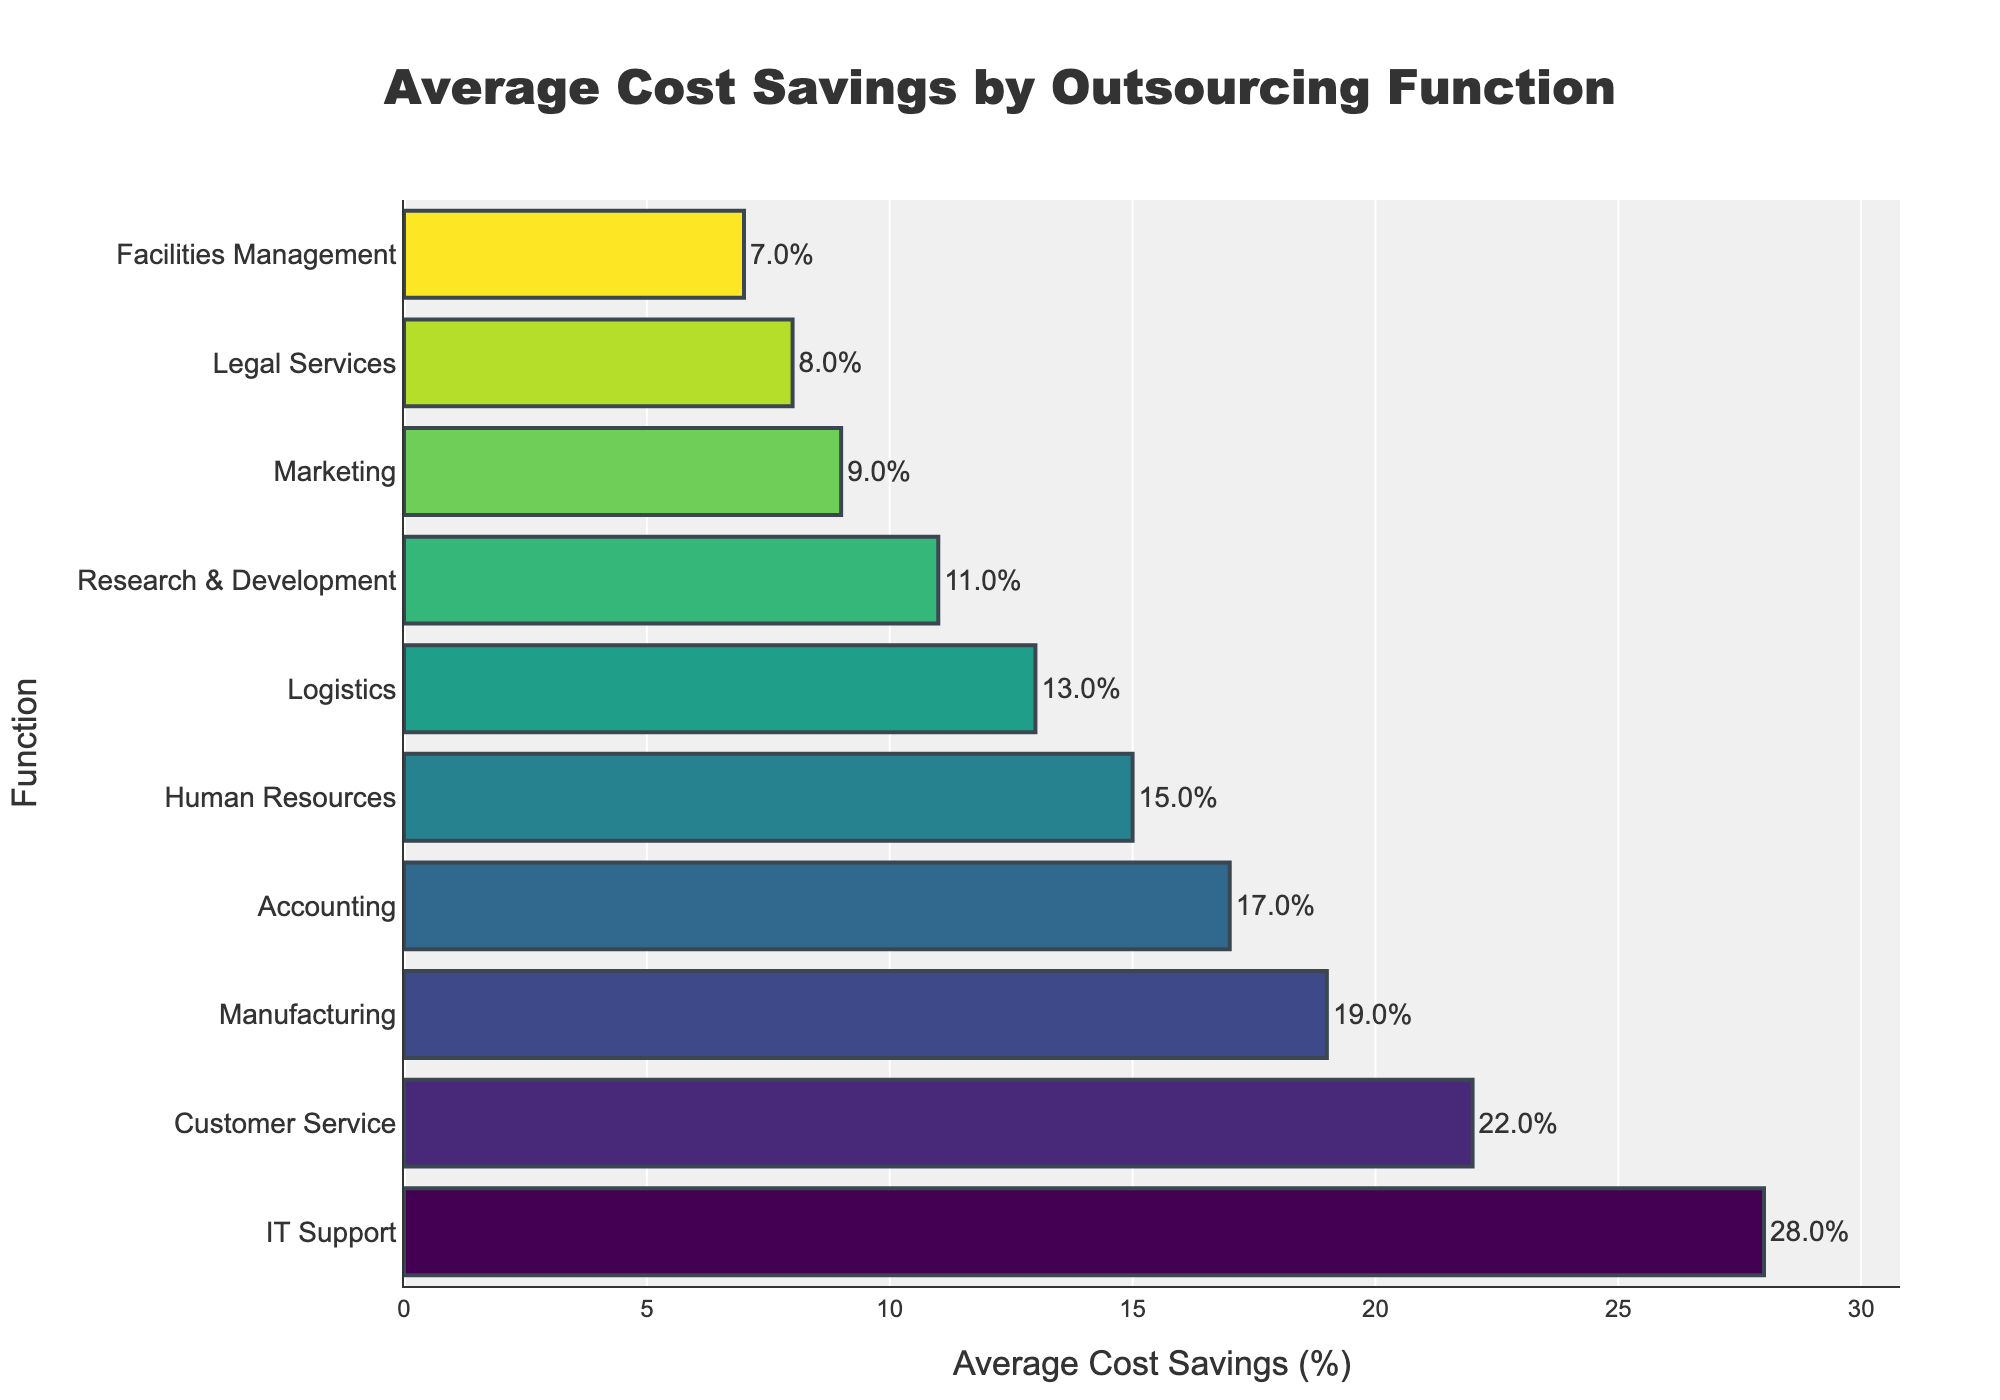What function has the highest average cost savings percentage according to the figure? The bar chart shows that IT Support has the highest average cost savings percentage, as it is at the top of the chart and has the longest bar.
Answer: IT Support Which functions have an average cost savings percentage greater than 20%? By examining the bars, only IT Support and Customer Service have bars extending beyond the 20% mark.
Answer: IT Support, Customer Service What is the difference in the average cost savings percentage between Manufacturing and Human Resources? Manufacturing has an average cost savings of 19%, and Human Resources has 15%. The difference is 19% - 15% = 4%.
Answer: 4% Which function has the smallest average cost savings percentage? The shortest bar represents Facilities Management with an average cost savings percentage of 7%.
Answer: Facilities Management How many functions have an average cost savings percentage lower than 10%? By counting the functions with bars shorter than the 10% mark, there are two: Marketing and Legal Services.
Answer: 2 Which function has a higher average cost savings percentage: Accounting or Research & Development? Comparing the lengths of the bars, Accounting has a longer bar at 17% compared to Research & Development at 11%.
Answer: Accounting What is the total average cost savings percentage of IT Support, Customer Service, and Manufacturing? Summing up the percentages for these functions: 28% + 22% + 19% = 69%.
Answer: 69% What is the average cost savings percentage for all functions displayed in the chart? Sum the percentages and divide by the number of functions: (28 + 22 + 19 + 17 + 15 + 13 + 11 + 9 + 8 + 7) / 10 = 14.9%.
Answer: 14.9% Which function saves less than half of the average cost savings percentage of Manufacturing? The average cost savings for Manufacturing is 19%. Half of this is 9.5%. Facilities Management, with 7%, saves less than this amount.
Answer: Facilities Management 